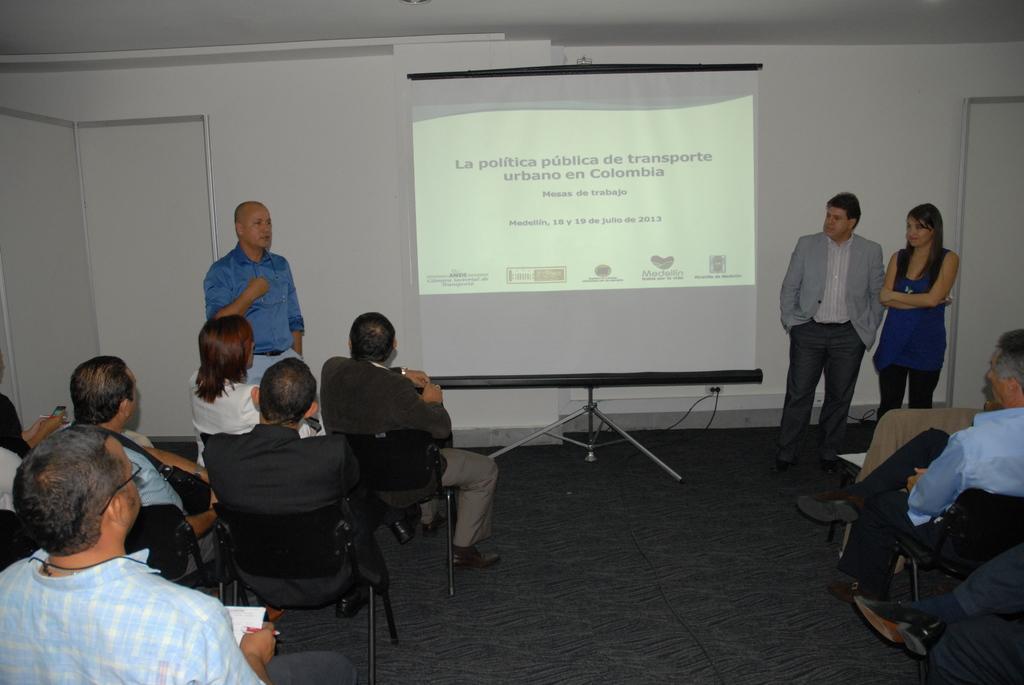In one or two sentences, can you explain what this image depicts? In this image I can see group of people sitting on the chairs, in front I can see a person standing wearing blue shirt, blue pant and I can also see the other person wearing gray blazer. Background I can see a projector screen and the wall is in white color. 